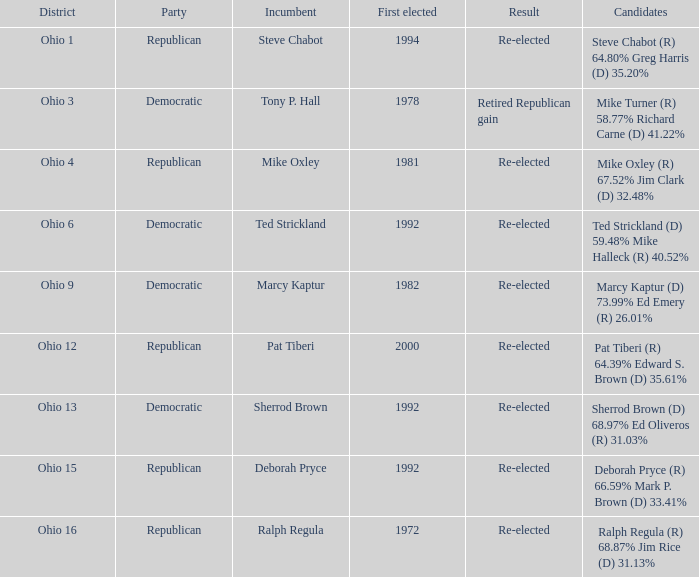Incumbent Deborah Pryce was a member of what party?  Republican. 